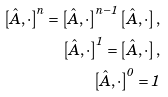Convert formula to latex. <formula><loc_0><loc_0><loc_500><loc_500>\left [ \hat { A } , \cdot \right ] ^ { n } = \left [ \hat { A } , \cdot \right ] ^ { n - 1 } \left [ \hat { A } , \cdot \right ] , \\ \left [ \hat { A } , \cdot \right ] ^ { 1 } = \left [ \hat { A } , \cdot \right ] , \\ \left [ \hat { A } , \cdot \right ] ^ { 0 } = 1</formula> 